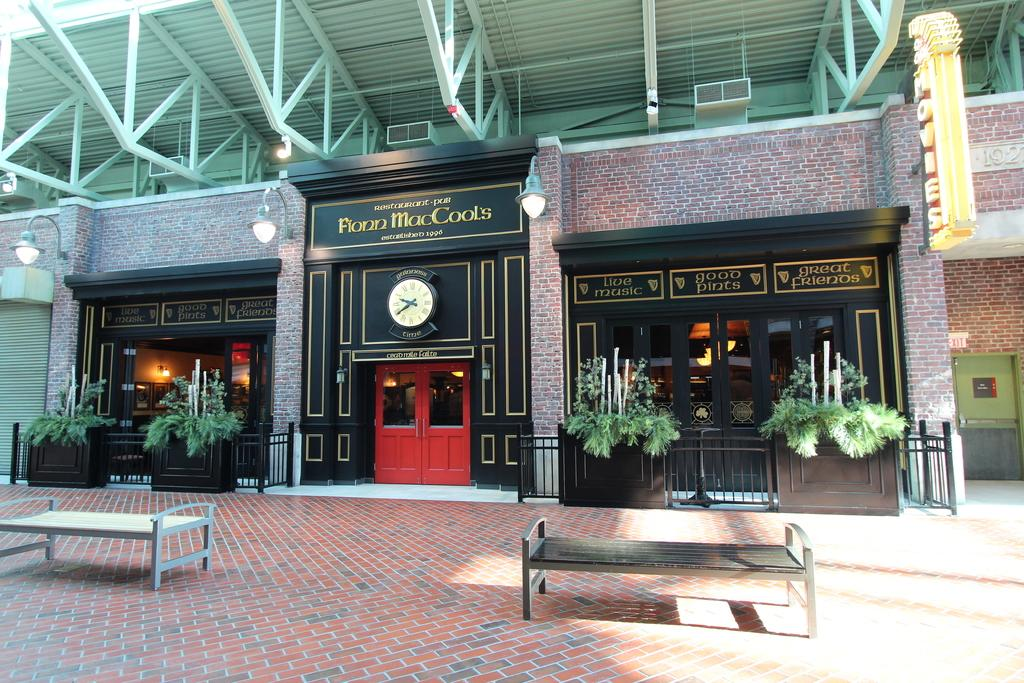What is the main subject of the image? The main subject of the image is the outside view of a building. Are there any objects or features near the building? Yes, there are benches in the image. What type of vegetation is present in the image? There are plants in the image. What can be seen illuminating the area in the image? There are lights in the image. What provides shelter at the top of the building? The roof is visible at the top of the building for shelter. Can you see any fairies dancing around the plants in the image? There are no fairies present in the image; it shows the outside view of a building with benches, plants, lights, and a roof. Is there any indication of a war happening in the image? There is no indication of a war or any conflict in the image; it depicts a peaceful scene with a building, benches, plants, lights, and a roof. 